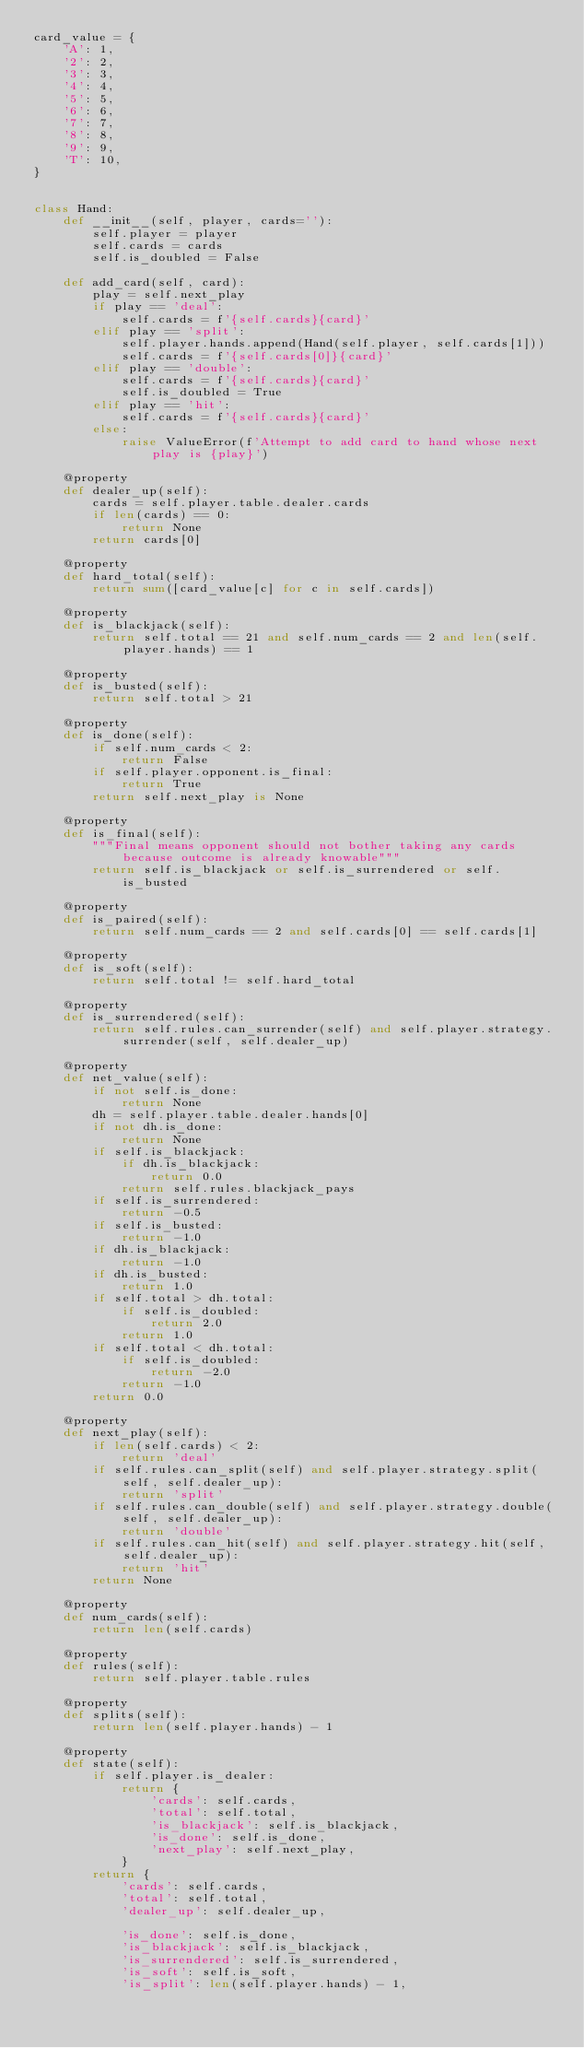Convert code to text. <code><loc_0><loc_0><loc_500><loc_500><_Python_>card_value = {
    'A': 1,
    '2': 2,
    '3': 3,
    '4': 4,
    '5': 5,
    '6': 6,
    '7': 7,
    '8': 8,
    '9': 9,
    'T': 10,
}


class Hand:
    def __init__(self, player, cards=''):
        self.player = player
        self.cards = cards
        self.is_doubled = False

    def add_card(self, card):
        play = self.next_play
        if play == 'deal':
            self.cards = f'{self.cards}{card}'
        elif play == 'split':
            self.player.hands.append(Hand(self.player, self.cards[1]))
            self.cards = f'{self.cards[0]}{card}'
        elif play == 'double':
            self.cards = f'{self.cards}{card}'
            self.is_doubled = True
        elif play == 'hit':
            self.cards = f'{self.cards}{card}'
        else:
            raise ValueError(f'Attempt to add card to hand whose next play is {play}')

    @property
    def dealer_up(self):
        cards = self.player.table.dealer.cards
        if len(cards) == 0:
            return None
        return cards[0]

    @property
    def hard_total(self):
        return sum([card_value[c] for c in self.cards])

    @property
    def is_blackjack(self):
        return self.total == 21 and self.num_cards == 2 and len(self.player.hands) == 1

    @property
    def is_busted(self):
        return self.total > 21

    @property
    def is_done(self):
        if self.num_cards < 2:
            return False
        if self.player.opponent.is_final:
            return True
        return self.next_play is None

    @property
    def is_final(self):
        """Final means opponent should not bother taking any cards because outcome is already knowable"""
        return self.is_blackjack or self.is_surrendered or self.is_busted

    @property
    def is_paired(self):
        return self.num_cards == 2 and self.cards[0] == self.cards[1]

    @property
    def is_soft(self):
        return self.total != self.hard_total

    @property
    def is_surrendered(self):
        return self.rules.can_surrender(self) and self.player.strategy.surrender(self, self.dealer_up)

    @property
    def net_value(self):
        if not self.is_done:
            return None
        dh = self.player.table.dealer.hands[0]
        if not dh.is_done:
            return None
        if self.is_blackjack:
            if dh.is_blackjack:
                return 0.0
            return self.rules.blackjack_pays
        if self.is_surrendered:
            return -0.5
        if self.is_busted:
            return -1.0
        if dh.is_blackjack:
            return -1.0
        if dh.is_busted:
            return 1.0
        if self.total > dh.total:
            if self.is_doubled:
                return 2.0
            return 1.0
        if self.total < dh.total:
            if self.is_doubled:
                return -2.0
            return -1.0
        return 0.0

    @property
    def next_play(self):
        if len(self.cards) < 2:
            return 'deal'
        if self.rules.can_split(self) and self.player.strategy.split(self, self.dealer_up):
            return 'split'
        if self.rules.can_double(self) and self.player.strategy.double(self, self.dealer_up):
            return 'double'
        if self.rules.can_hit(self) and self.player.strategy.hit(self, self.dealer_up):
            return 'hit'
        return None

    @property
    def num_cards(self):
        return len(self.cards)

    @property
    def rules(self):
        return self.player.table.rules

    @property
    def splits(self):
        return len(self.player.hands) - 1

    @property
    def state(self):
        if self.player.is_dealer:
            return {
                'cards': self.cards,
                'total': self.total,
                'is_blackjack': self.is_blackjack,
                'is_done': self.is_done,
                'next_play': self.next_play,
            }
        return {
            'cards': self.cards,
            'total': self.total,
            'dealer_up': self.dealer_up,

            'is_done': self.is_done,
            'is_blackjack': self.is_blackjack,
            'is_surrendered': self.is_surrendered,
            'is_soft': self.is_soft,
            'is_split': len(self.player.hands) - 1,</code> 